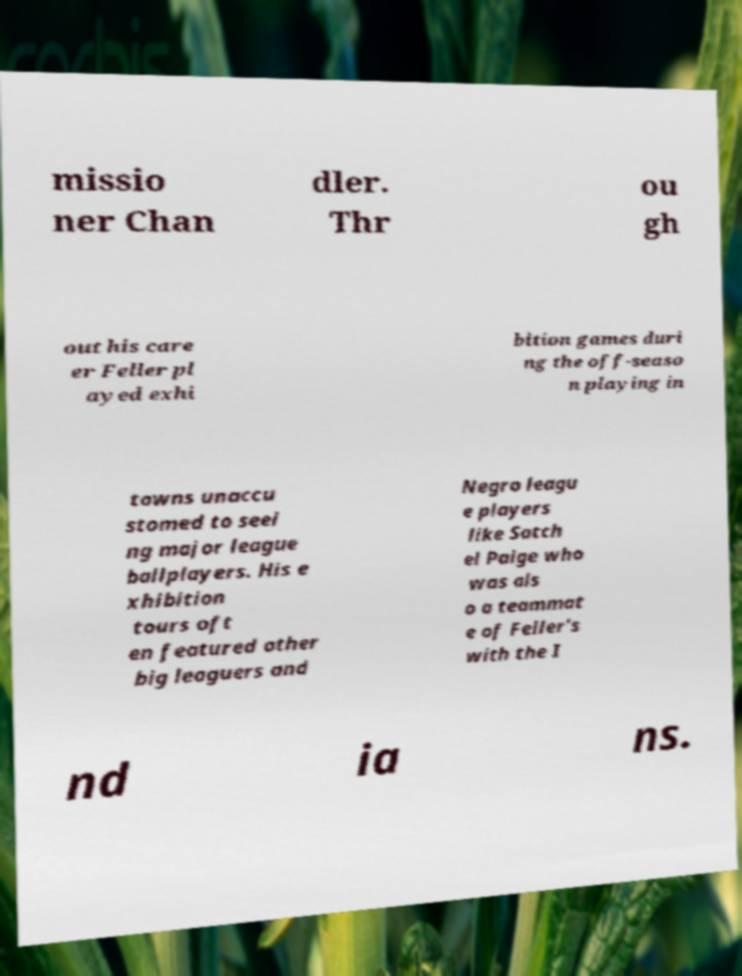Can you read and provide the text displayed in the image?This photo seems to have some interesting text. Can you extract and type it out for me? missio ner Chan dler. Thr ou gh out his care er Feller pl ayed exhi bition games duri ng the off-seaso n playing in towns unaccu stomed to seei ng major league ballplayers. His e xhibition tours oft en featured other big leaguers and Negro leagu e players like Satch el Paige who was als o a teammat e of Feller's with the I nd ia ns. 